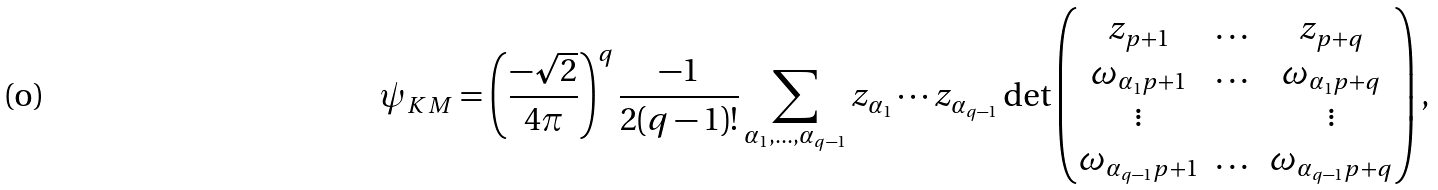<formula> <loc_0><loc_0><loc_500><loc_500>\psi _ { K M } = \left ( \frac { - \sqrt { 2 } } { 4 \pi } \right ) ^ { q } \frac { - 1 } { 2 ( q - 1 ) ! } \sum _ { \alpha _ { 1 } , \dots , \alpha _ { q - 1 } } z _ { \alpha _ { 1 } } \cdots z _ { \alpha _ { q - 1 } } \det \begin{pmatrix} z _ { p + 1 } & \dots & z _ { p + q } \\ \omega _ { \alpha _ { 1 } p + 1 } & \dots & \omega _ { \alpha _ { 1 } p + q } \\ \vdots & & \vdots \\ \omega _ { \alpha _ { q - 1 } p + 1 } & \dots & \omega _ { \alpha _ { q - 1 } p + q } \end{pmatrix} ,</formula> 